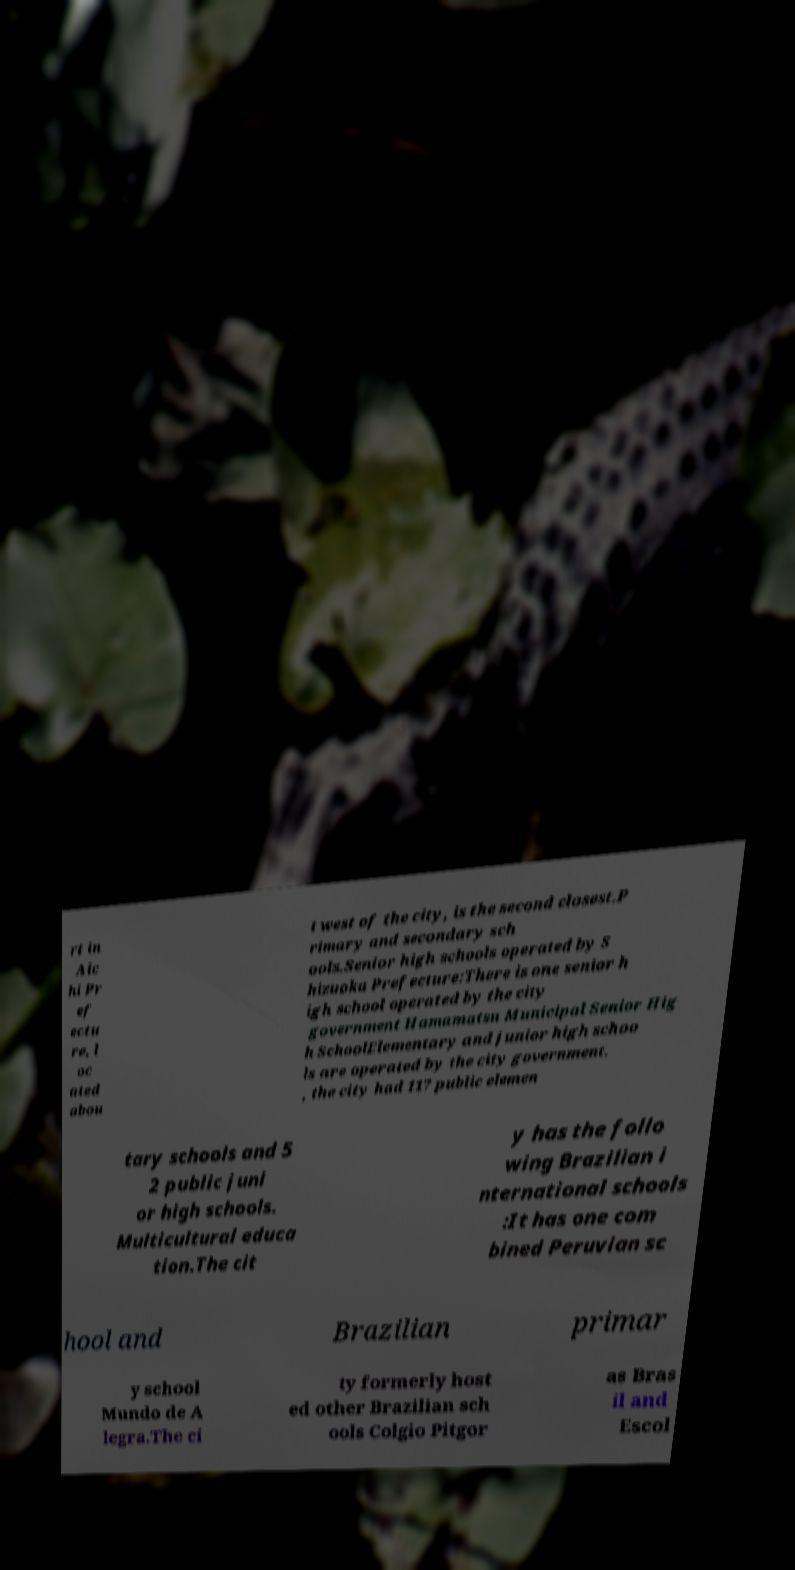What messages or text are displayed in this image? I need them in a readable, typed format. rt in Aic hi Pr ef ectu re, l oc ated abou t west of the city, is the second closest.P rimary and secondary sch ools.Senior high schools operated by S hizuoka Prefecture:There is one senior h igh school operated by the city government Hamamatsu Municipal Senior Hig h SchoolElementary and junior high schoo ls are operated by the city government. , the city had 117 public elemen tary schools and 5 2 public juni or high schools. Multicultural educa tion.The cit y has the follo wing Brazilian i nternational schools :It has one com bined Peruvian sc hool and Brazilian primar y school Mundo de A legra.The ci ty formerly host ed other Brazilian sch ools Colgio Pitgor as Bras il and Escol 